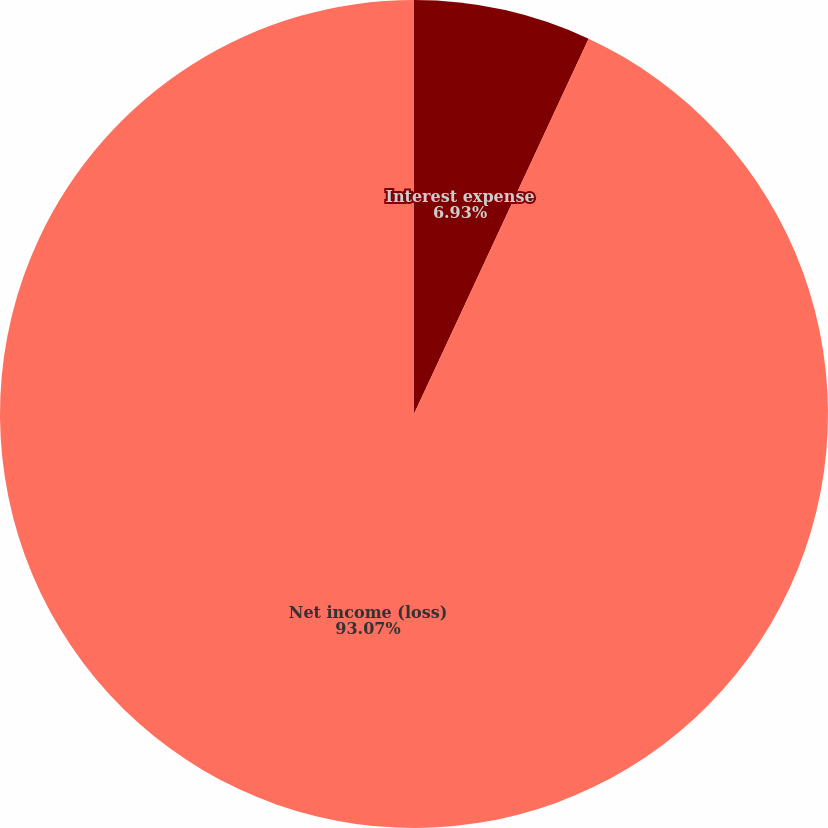Convert chart to OTSL. <chart><loc_0><loc_0><loc_500><loc_500><pie_chart><fcel>Interest expense<fcel>Net income (loss)<nl><fcel>6.93%<fcel>93.07%<nl></chart> 